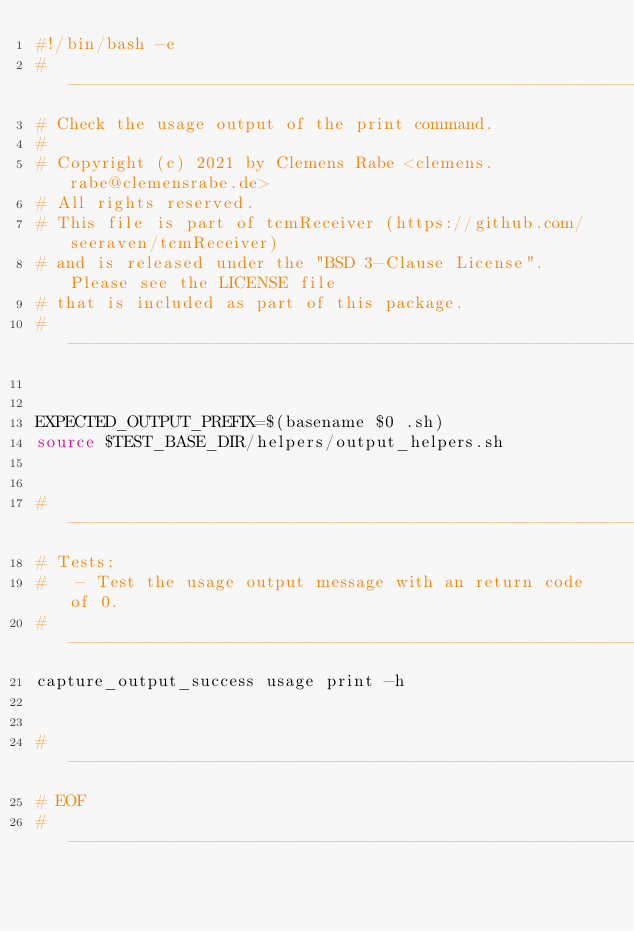<code> <loc_0><loc_0><loc_500><loc_500><_Bash_>#!/bin/bash -e
# ----------------------------------------------------------------------------
# Check the usage output of the print command.
#
# Copyright (c) 2021 by Clemens Rabe <clemens.rabe@clemensrabe.de>
# All rights reserved.
# This file is part of tcmReceiver (https://github.com/seeraven/tcmReceiver)
# and is released under the "BSD 3-Clause License". Please see the LICENSE file
# that is included as part of this package.
# ----------------------------------------------------------------------------


EXPECTED_OUTPUT_PREFIX=$(basename $0 .sh)
source $TEST_BASE_DIR/helpers/output_helpers.sh


# -----------------------------------------------------------------------------
# Tests:
#   - Test the usage output message with an return code of 0.
# -----------------------------------------------------------------------------
capture_output_success usage print -h


# -----------------------------------------------------------------------------
# EOF
# -----------------------------------------------------------------------------
</code> 